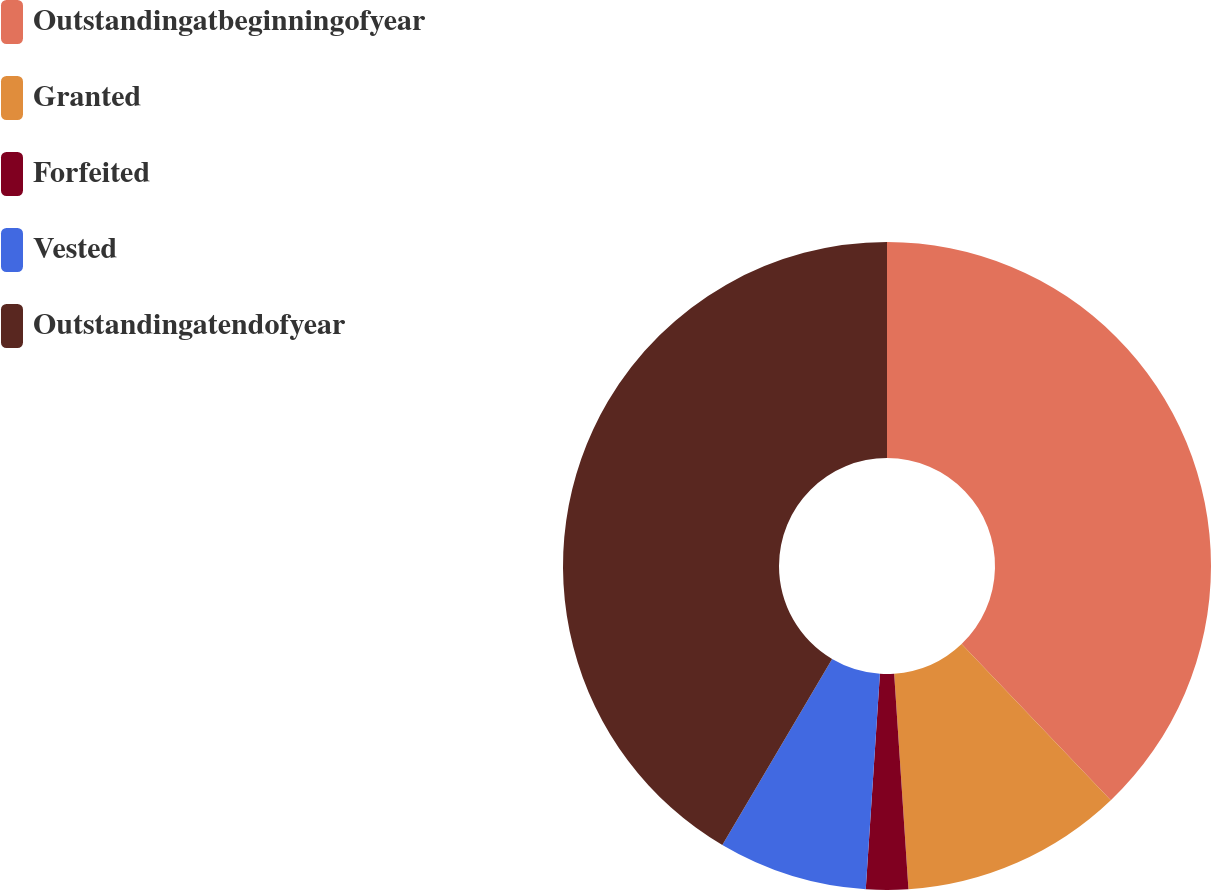Convert chart. <chart><loc_0><loc_0><loc_500><loc_500><pie_chart><fcel>Outstandingatbeginningofyear<fcel>Granted<fcel>Forfeited<fcel>Vested<fcel>Outstandingatendofyear<nl><fcel>37.86%<fcel>11.08%<fcel>2.1%<fcel>7.44%<fcel>41.51%<nl></chart> 